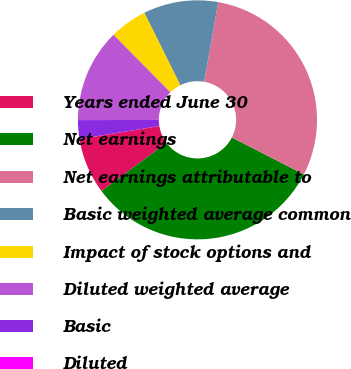Convert chart. <chart><loc_0><loc_0><loc_500><loc_500><pie_chart><fcel>Years ended June 30<fcel>Net earnings<fcel>Net earnings attributable to<fcel>Basic weighted average common<fcel>Impact of stock options and<fcel>Diluted weighted average<fcel>Basic<fcel>Diluted<nl><fcel>7.59%<fcel>32.29%<fcel>29.77%<fcel>10.11%<fcel>5.06%<fcel>12.64%<fcel>2.53%<fcel>0.01%<nl></chart> 